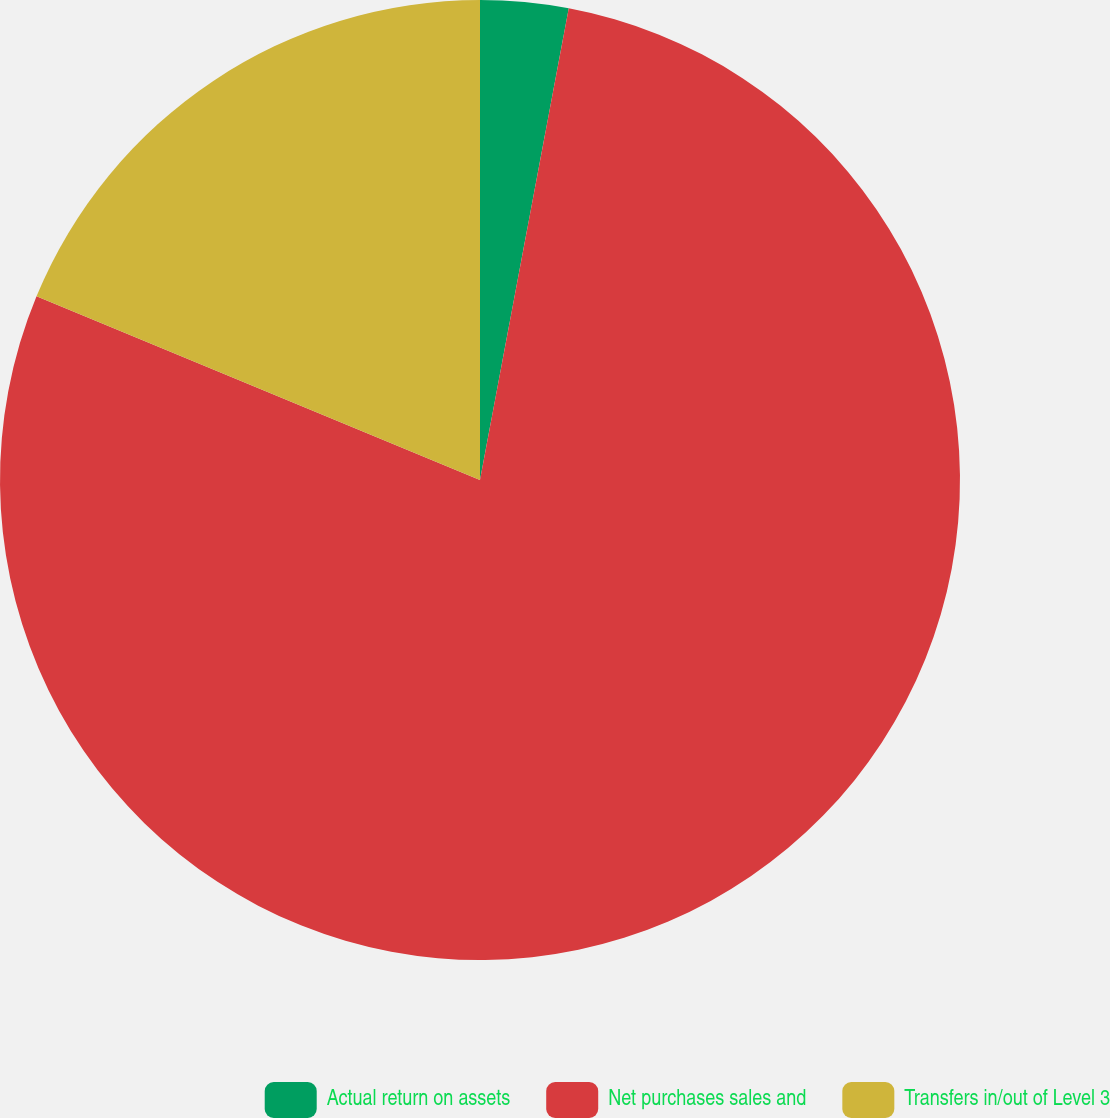Convert chart. <chart><loc_0><loc_0><loc_500><loc_500><pie_chart><fcel>Actual return on assets<fcel>Net purchases sales and<fcel>Transfers in/out of Level 3<nl><fcel>2.96%<fcel>78.29%<fcel>18.75%<nl></chart> 